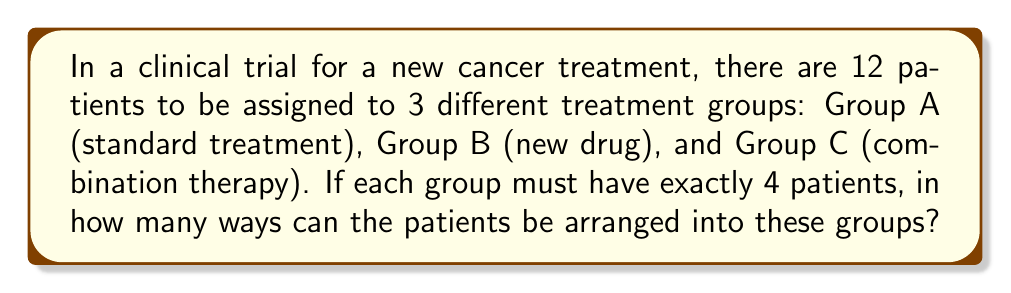Give your solution to this math problem. Let's approach this step-by-step:

1) This is a partition problem, where we need to divide 12 patients into 3 groups of 4 each.

2) We can solve this using the concept of multinomial coefficients.

3) The formula for multinomial coefficient is:

   $$\binom{n}{n_1,n_2,...,n_k} = \frac{n!}{n_1!n_2!...n_k!}$$

   where $n$ is the total number of items, and $n_1, n_2, ..., n_k$ are the sizes of each group.

4) In our case:
   $n = 12$ (total patients)
   $n_1 = n_2 = n_3 = 4$ (4 patients in each group)

5) Plugging into the formula:

   $$\binom{12}{4,4,4} = \frac{12!}{4!4!4!}$$

6) Calculating:
   $$\frac{12!}{4!4!4!} = \frac{12 \times 11 \times 10 \times 9 \times 8!}{(4 \times 3 \times 2 \times 1) \times (4 \times 3 \times 2 \times 1) \times (4 \times 3 \times 2 \times 1)}$$

7) Simplifying:
   $$\frac{12 \times 11 \times 10 \times 9}{24} = 11 \times 10 \times 9 = 990$$

Therefore, there are 990 ways to arrange the patients into the three groups.
Answer: 990 